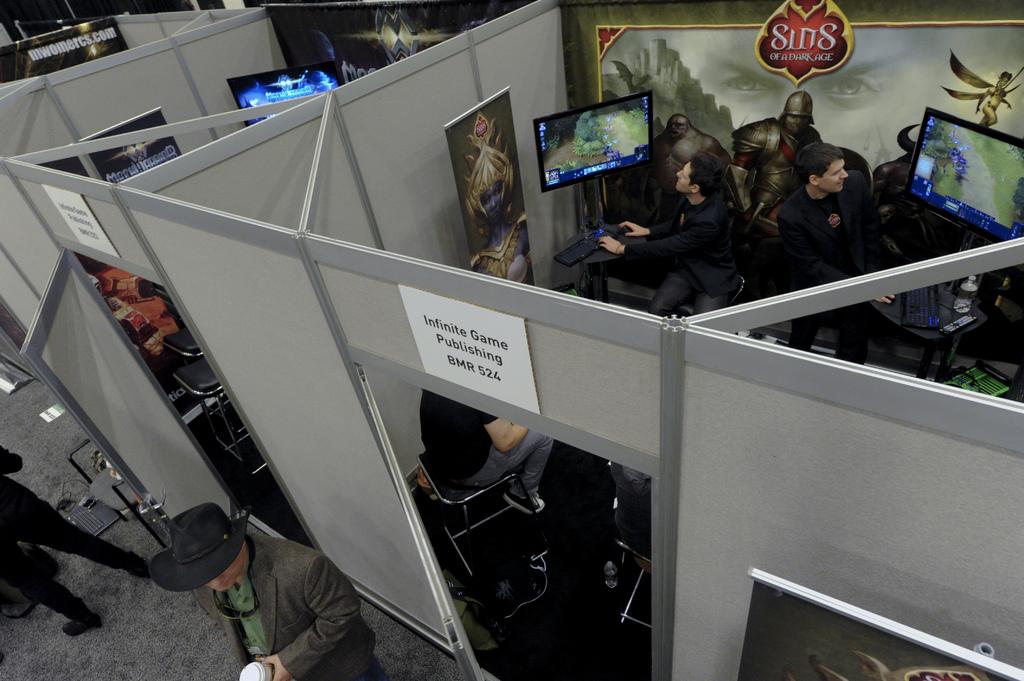What is the name of the game being played?
Provide a succinct answer. Sins. What is the room number?
Your answer should be compact. 524. 